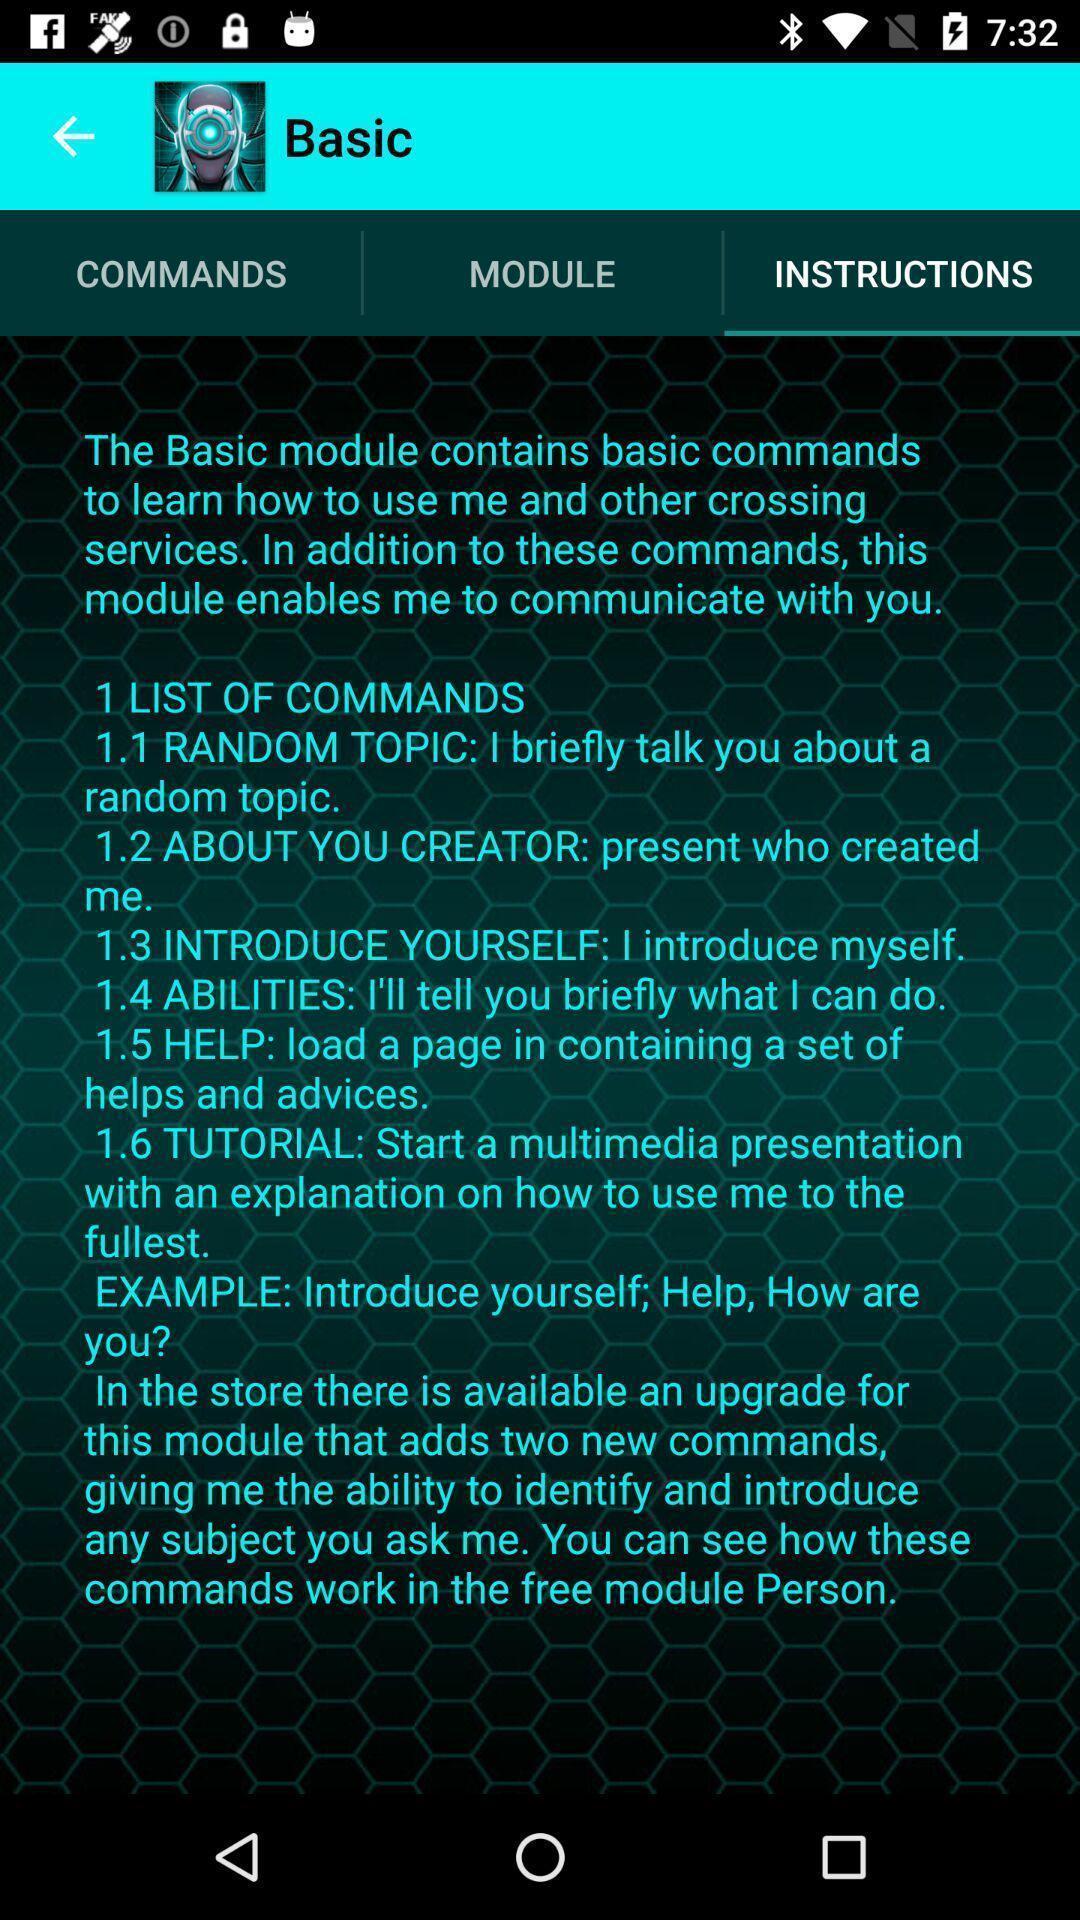Explain the elements present in this screenshot. Page displaying list of instructions. 